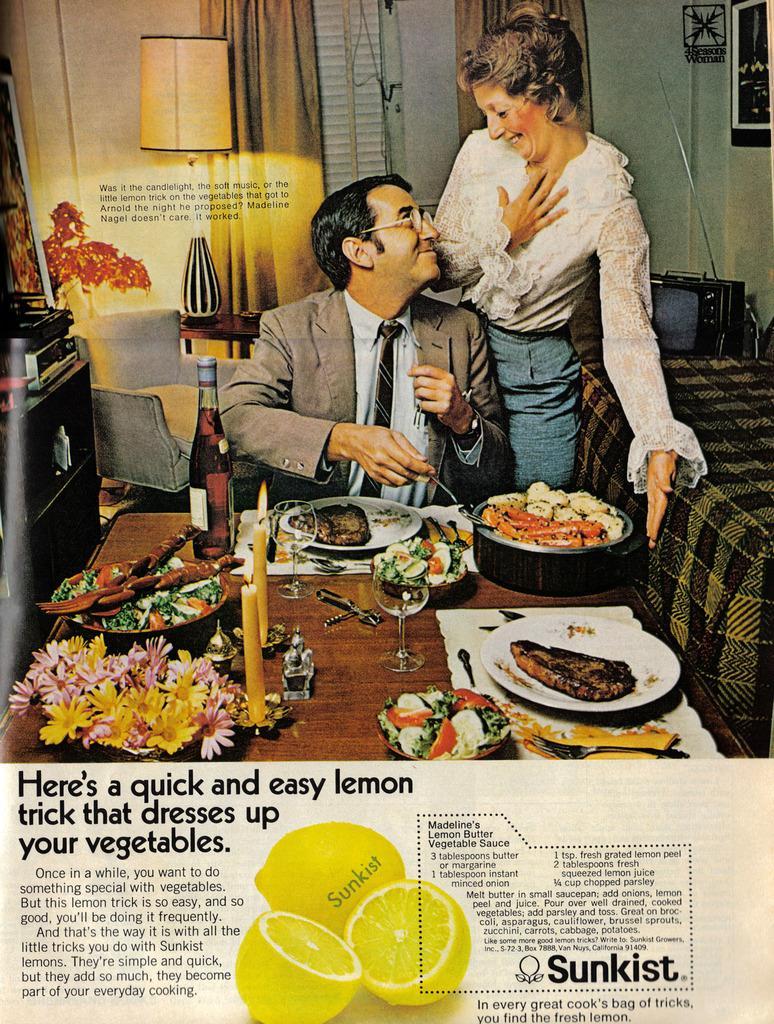In one or two sentences, can you explain what this image depicts? This might be a poster, in this image at the bottom there are lemons and there is a text and in the center there is one man and one woman and a man is sitting and he is holding a spoon. And there is a table, on the table there are some plates, flowers, and in the plates there is food and also there are glasses and spoons. And in the background there is a bed, television, chairs, lamp, curtains, wall, window and some objects. 